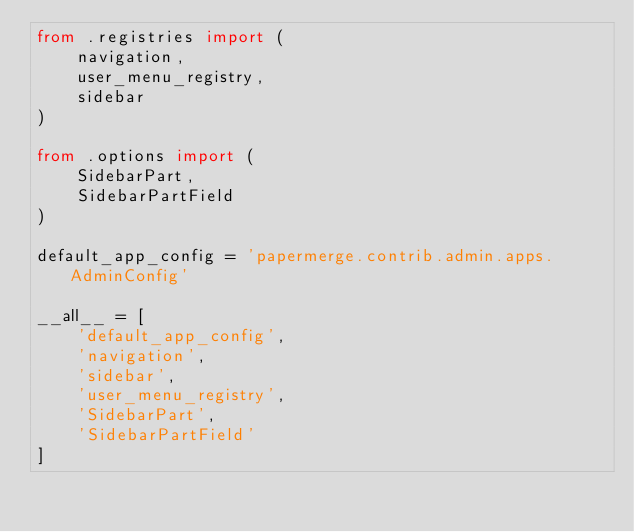Convert code to text. <code><loc_0><loc_0><loc_500><loc_500><_Python_>from .registries import (
    navigation,
    user_menu_registry,
    sidebar
)

from .options import (
    SidebarPart,
    SidebarPartField
)

default_app_config = 'papermerge.contrib.admin.apps.AdminConfig'

__all__ = [
    'default_app_config',
    'navigation',
    'sidebar',
    'user_menu_registry',
    'SidebarPart',
    'SidebarPartField'
]
</code> 